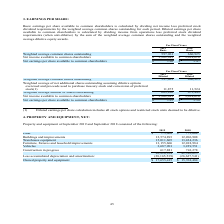According to Amcon Distributing's financial document, How is basic earnings per share available to common shareholders calculated? dividing net income less preferred stock dividend requirements by the weighted average common shares outstanding for each period.. The document states: "available to common shareholders is calculated by dividing net income less preferred stock dividend requirements by the weighted average common shares..." Also, How is diluted earnings per share available to common shareholders calculated? dividing income from operations less preferred stock dividend requirements (when anti-dilutive) by the sum of the weighted average common shares outstanding and the weighted average dilutive equity awards.. The document states: "available to common shareholders is calculated by dividing income from operations less preferred stock dividend requirements (when anti-dilutive) by t..." Also, What are the respective weighted average basic common shares outstanding for fiscal years 2018 and 2019? The document shows two values: 660,925 and 597,961. From the document: "eighted average common shares outstanding 597,961 660,925 Weighted average common shares outstanding 597,961 660,925..." Also, can you calculate: What is the percentage change in the weighted average basic common shares outstanding between 2018 and 2019? To answer this question, I need to perform calculations using the financial data. The calculation is: (597,961 - 660,925)/660,925 , which equals -9.53 (percentage). This is based on the information: "eighted average common shares outstanding 597,961 660,925 Weighted average common shares outstanding 597,961 660,925..." The key data points involved are: 597,961, 660,925. Also, can you calculate: What is the percentage change in the net income available to common shareholders between 2018 and 2019? To answer this question, I need to perform calculations using the financial data. The calculation is: (3,202,943 - 3,614,610)/3,614,610 , which equals -11.39 (percentage). This is based on the information: "Net income available to common shareholders $ 3,202,943 $ 3,614,610 me available to common shareholders $ 3,202,943 $ 3,614,610..." The key data points involved are: 3,202,943, 3,614,610. Also, can you calculate: What is the average net earnings per share available to common basic shareholders in 2018 and 2019? To answer this question, I need to perform calculations using the financial data. The calculation is: (5.47 + 5.36)/2 , which equals 5.42. This is based on the information: "r share available to common shareholders $ 5.36 $ 5.47 ings per share available to common shareholders $ 5.36 $ 5.47..." The key data points involved are: 5.36, 5.47. 